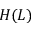<formula> <loc_0><loc_0><loc_500><loc_500>H ( L )</formula> 